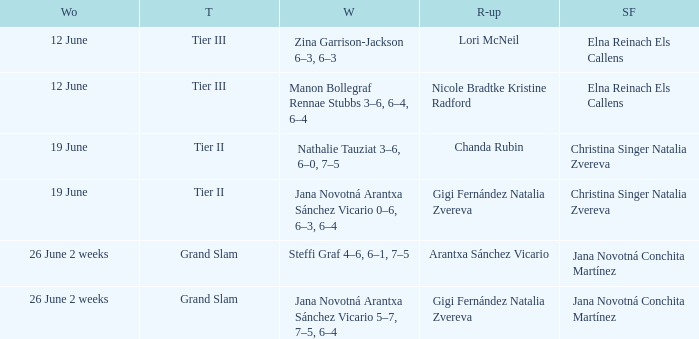When the Tier is listed as tier iii, who is the Winner? Zina Garrison-Jackson 6–3, 6–3, Manon Bollegraf Rennae Stubbs 3–6, 6–4, 6–4. 